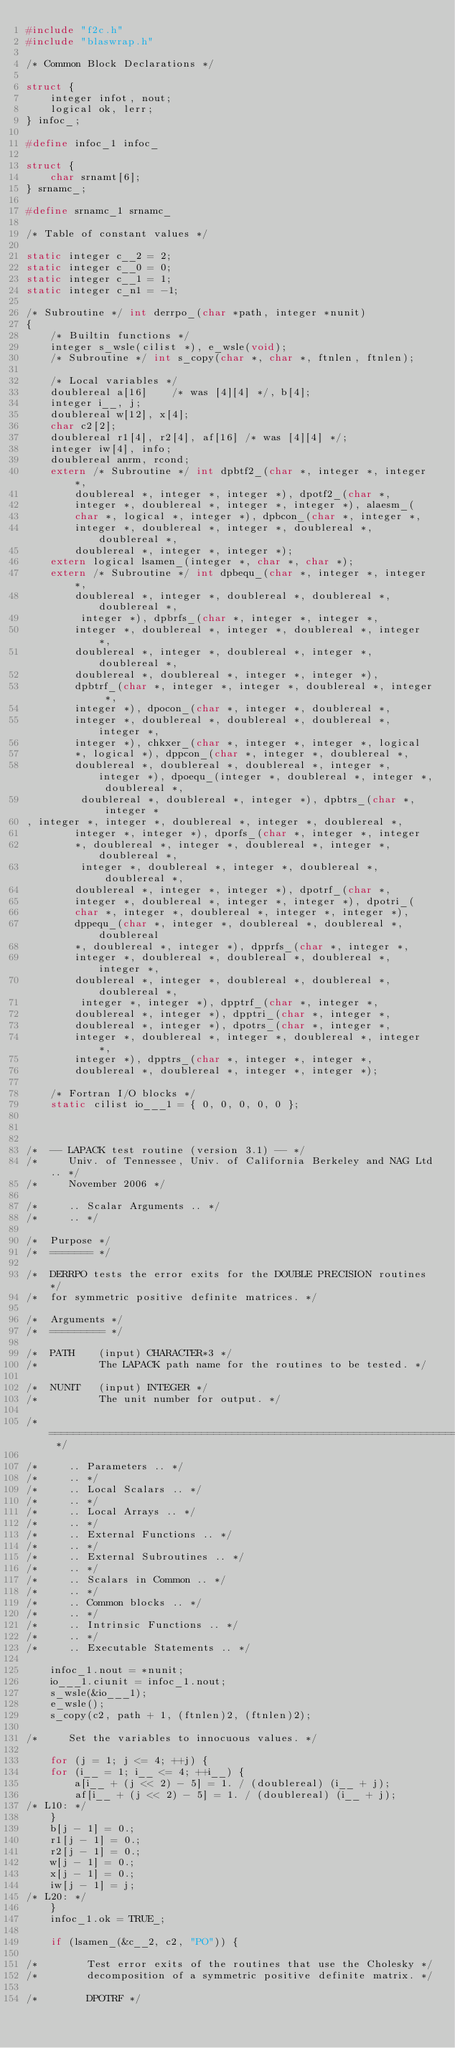<code> <loc_0><loc_0><loc_500><loc_500><_C_>#include "f2c.h"
#include "blaswrap.h"

/* Common Block Declarations */

struct {
    integer infot, nout;
    logical ok, lerr;
} infoc_;

#define infoc_1 infoc_

struct {
    char srnamt[6];
} srnamc_;

#define srnamc_1 srnamc_

/* Table of constant values */

static integer c__2 = 2;
static integer c__0 = 0;
static integer c__1 = 1;
static integer c_n1 = -1;

/* Subroutine */ int derrpo_(char *path, integer *nunit)
{
    /* Builtin functions */
    integer s_wsle(cilist *), e_wsle(void);
    /* Subroutine */ int s_copy(char *, char *, ftnlen, ftnlen);

    /* Local variables */
    doublereal a[16]	/* was [4][4] */, b[4];
    integer i__, j;
    doublereal w[12], x[4];
    char c2[2];
    doublereal r1[4], r2[4], af[16]	/* was [4][4] */;
    integer iw[4], info;
    doublereal anrm, rcond;
    extern /* Subroutine */ int dpbtf2_(char *, integer *, integer *, 
	    doublereal *, integer *, integer *), dpotf2_(char *, 
	    integer *, doublereal *, integer *, integer *), alaesm_(
	    char *, logical *, integer *), dpbcon_(char *, integer *, 
	    integer *, doublereal *, integer *, doublereal *, doublereal *, 
	    doublereal *, integer *, integer *);
    extern logical lsamen_(integer *, char *, char *);
    extern /* Subroutine */ int dpbequ_(char *, integer *, integer *, 
	    doublereal *, integer *, doublereal *, doublereal *, doublereal *, 
	     integer *), dpbrfs_(char *, integer *, integer *, 
	    integer *, doublereal *, integer *, doublereal *, integer *, 
	    doublereal *, integer *, doublereal *, integer *, doublereal *, 
	    doublereal *, doublereal *, integer *, integer *), 
	    dpbtrf_(char *, integer *, integer *, doublereal *, integer *, 
	    integer *), dpocon_(char *, integer *, doublereal *, 
	    integer *, doublereal *, doublereal *, doublereal *, integer *, 
	    integer *), chkxer_(char *, integer *, integer *, logical 
	    *, logical *), dppcon_(char *, integer *, doublereal *, 
	    doublereal *, doublereal *, doublereal *, integer *, integer *), dpoequ_(integer *, doublereal *, integer *, doublereal *, 
	     doublereal *, doublereal *, integer *), dpbtrs_(char *, integer *
, integer *, integer *, doublereal *, integer *, doublereal *, 
	    integer *, integer *), dporfs_(char *, integer *, integer 
	    *, doublereal *, integer *, doublereal *, integer *, doublereal *, 
	     integer *, doublereal *, integer *, doublereal *, doublereal *, 
	    doublereal *, integer *, integer *), dpotrf_(char *, 
	    integer *, doublereal *, integer *, integer *), dpotri_(
	    char *, integer *, doublereal *, integer *, integer *), 
	    dppequ_(char *, integer *, doublereal *, doublereal *, doublereal 
	    *, doublereal *, integer *), dpprfs_(char *, integer *, 
	    integer *, doublereal *, doublereal *, doublereal *, integer *, 
	    doublereal *, integer *, doublereal *, doublereal *, doublereal *, 
	     integer *, integer *), dpptrf_(char *, integer *, 
	    doublereal *, integer *), dpptri_(char *, integer *, 
	    doublereal *, integer *), dpotrs_(char *, integer *, 
	    integer *, doublereal *, integer *, doublereal *, integer *, 
	    integer *), dpptrs_(char *, integer *, integer *, 
	    doublereal *, doublereal *, integer *, integer *);

    /* Fortran I/O blocks */
    static cilist io___1 = { 0, 0, 0, 0, 0 };



/*  -- LAPACK test routine (version 3.1) -- */
/*     Univ. of Tennessee, Univ. of California Berkeley and NAG Ltd.. */
/*     November 2006 */

/*     .. Scalar Arguments .. */
/*     .. */

/*  Purpose */
/*  ======= */

/*  DERRPO tests the error exits for the DOUBLE PRECISION routines */
/*  for symmetric positive definite matrices. */

/*  Arguments */
/*  ========= */

/*  PATH    (input) CHARACTER*3 */
/*          The LAPACK path name for the routines to be tested. */

/*  NUNIT   (input) INTEGER */
/*          The unit number for output. */

/*  ===================================================================== */

/*     .. Parameters .. */
/*     .. */
/*     .. Local Scalars .. */
/*     .. */
/*     .. Local Arrays .. */
/*     .. */
/*     .. External Functions .. */
/*     .. */
/*     .. External Subroutines .. */
/*     .. */
/*     .. Scalars in Common .. */
/*     .. */
/*     .. Common blocks .. */
/*     .. */
/*     .. Intrinsic Functions .. */
/*     .. */
/*     .. Executable Statements .. */

    infoc_1.nout = *nunit;
    io___1.ciunit = infoc_1.nout;
    s_wsle(&io___1);
    e_wsle();
    s_copy(c2, path + 1, (ftnlen)2, (ftnlen)2);

/*     Set the variables to innocuous values. */

    for (j = 1; j <= 4; ++j) {
	for (i__ = 1; i__ <= 4; ++i__) {
	    a[i__ + (j << 2) - 5] = 1. / (doublereal) (i__ + j);
	    af[i__ + (j << 2) - 5] = 1. / (doublereal) (i__ + j);
/* L10: */
	}
	b[j - 1] = 0.;
	r1[j - 1] = 0.;
	r2[j - 1] = 0.;
	w[j - 1] = 0.;
	x[j - 1] = 0.;
	iw[j - 1] = j;
/* L20: */
    }
    infoc_1.ok = TRUE_;

    if (lsamen_(&c__2, c2, "PO")) {

/*        Test error exits of the routines that use the Cholesky */
/*        decomposition of a symmetric positive definite matrix. */

/*        DPOTRF */
</code> 